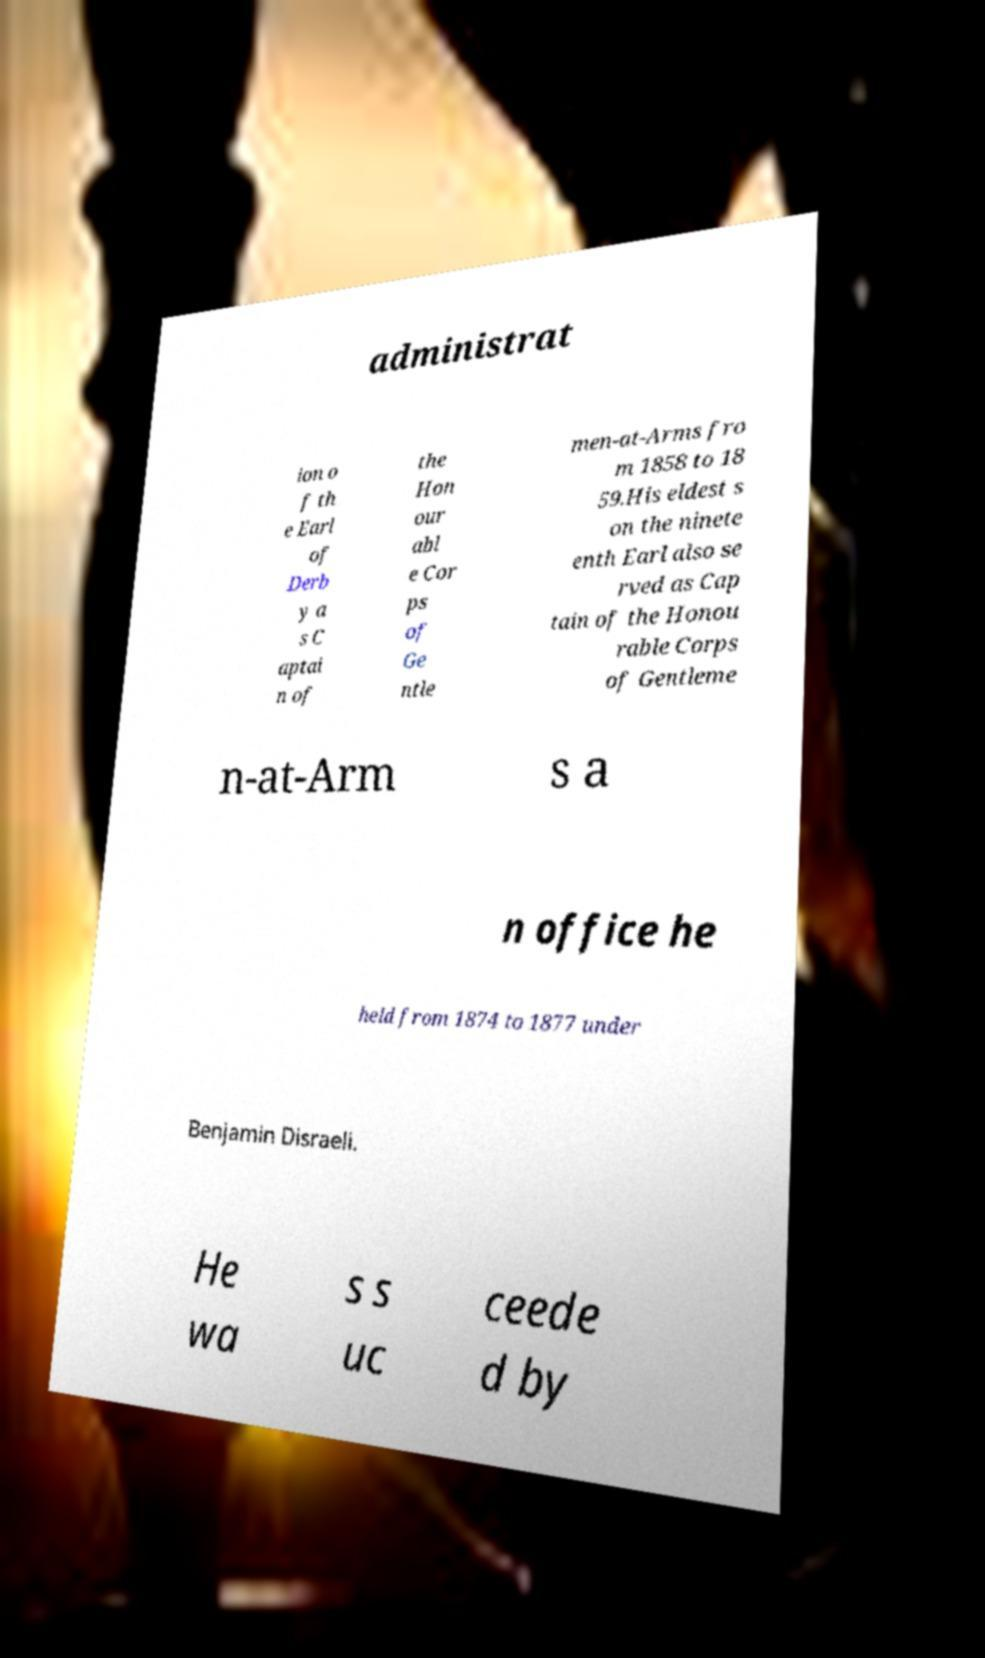There's text embedded in this image that I need extracted. Can you transcribe it verbatim? administrat ion o f th e Earl of Derb y a s C aptai n of the Hon our abl e Cor ps of Ge ntle men-at-Arms fro m 1858 to 18 59.His eldest s on the ninete enth Earl also se rved as Cap tain of the Honou rable Corps of Gentleme n-at-Arm s a n office he held from 1874 to 1877 under Benjamin Disraeli. He wa s s uc ceede d by 